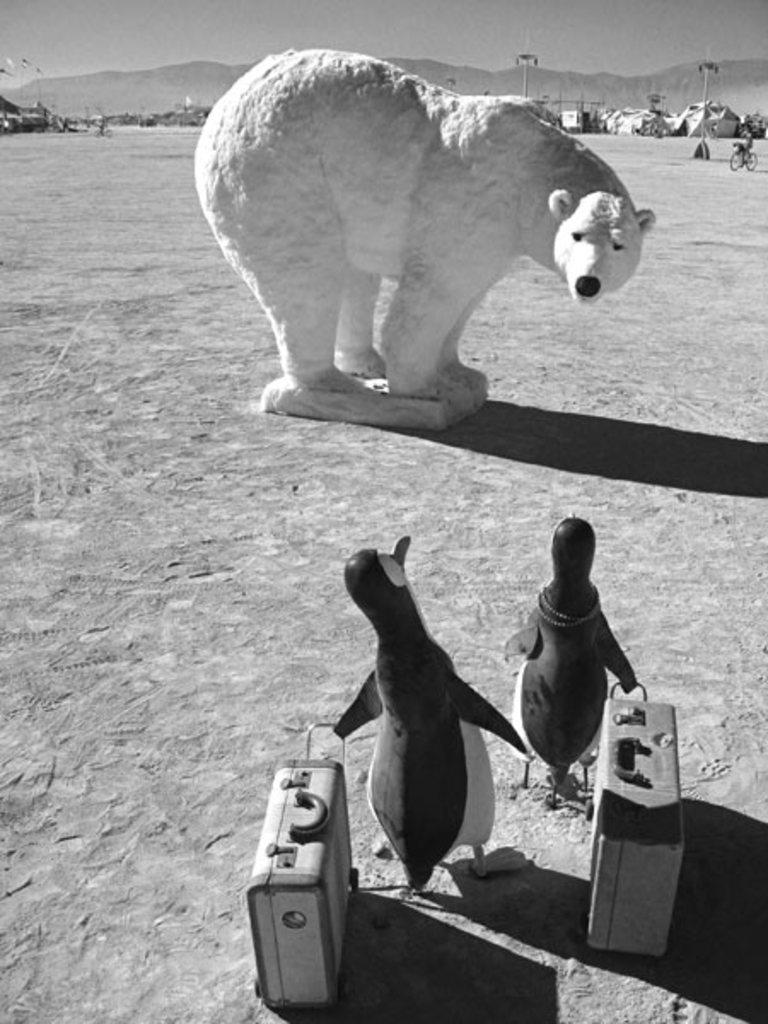What is the main subject in the center of the image? There is a statue of a bear in the center of the image. What other statues can be seen in the image? There are statues of penguins in the image. What objects are present at the bottom side of the image? There are suitcases in the image. Where are the statues of penguins and suitcases located in relation to the bear statue? The statues of penguins and suitcases are at the bottom side of the image. What type of light can be seen reflecting off the bear statue in the image? There is no mention of light reflecting off the bear statue in the image. 